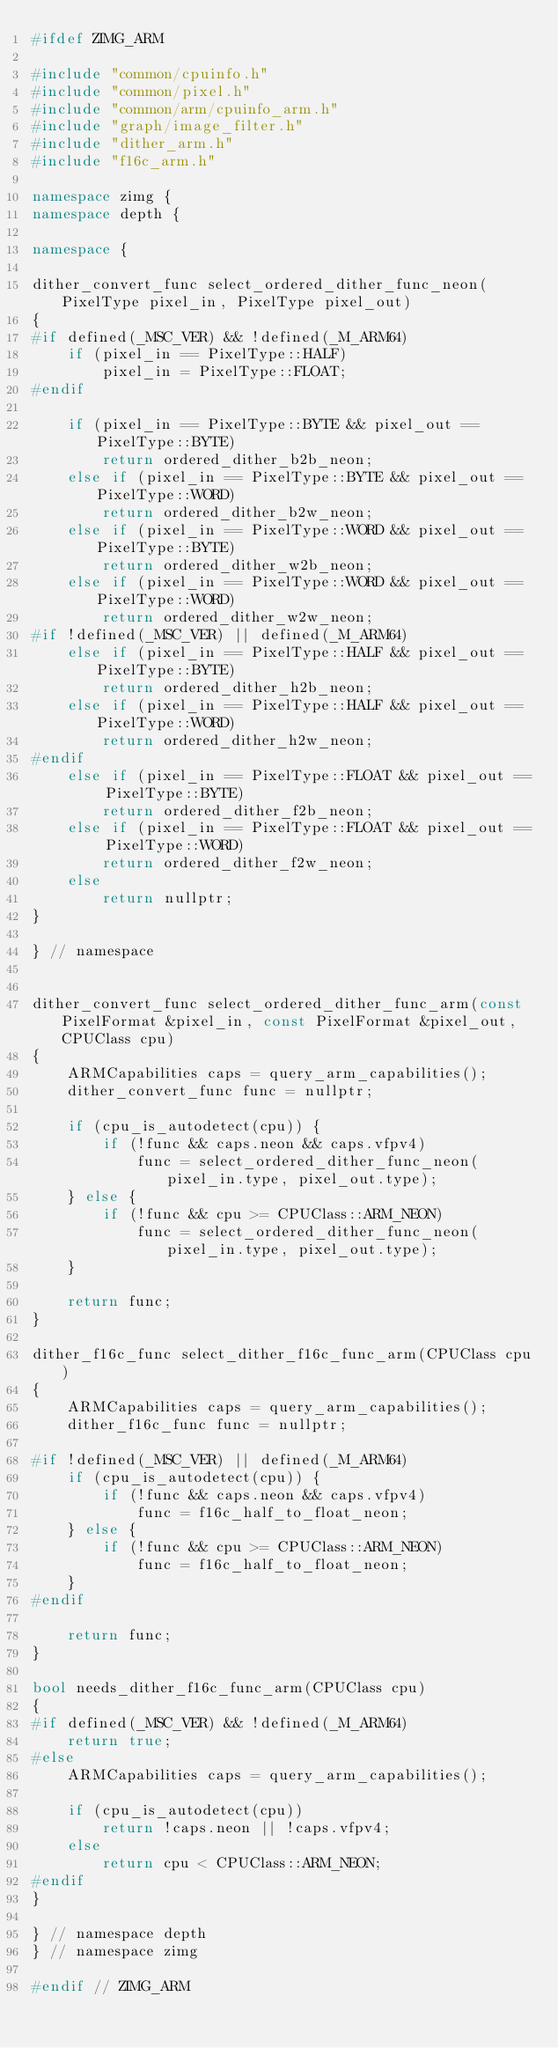Convert code to text. <code><loc_0><loc_0><loc_500><loc_500><_C++_>#ifdef ZIMG_ARM

#include "common/cpuinfo.h"
#include "common/pixel.h"
#include "common/arm/cpuinfo_arm.h"
#include "graph/image_filter.h"
#include "dither_arm.h"
#include "f16c_arm.h"

namespace zimg {
namespace depth {

namespace {

dither_convert_func select_ordered_dither_func_neon(PixelType pixel_in, PixelType pixel_out)
{
#if defined(_MSC_VER) && !defined(_M_ARM64)
	if (pixel_in == PixelType::HALF)
		pixel_in = PixelType::FLOAT;
#endif

	if (pixel_in == PixelType::BYTE && pixel_out == PixelType::BYTE)
		return ordered_dither_b2b_neon;
	else if (pixel_in == PixelType::BYTE && pixel_out == PixelType::WORD)
		return ordered_dither_b2w_neon;
	else if (pixel_in == PixelType::WORD && pixel_out == PixelType::BYTE)
		return ordered_dither_w2b_neon;
	else if (pixel_in == PixelType::WORD && pixel_out == PixelType::WORD)
		return ordered_dither_w2w_neon;
#if !defined(_MSC_VER) || defined(_M_ARM64)
	else if (pixel_in == PixelType::HALF && pixel_out == PixelType::BYTE)
		return ordered_dither_h2b_neon;
	else if (pixel_in == PixelType::HALF && pixel_out == PixelType::WORD)
		return ordered_dither_h2w_neon;
#endif
	else if (pixel_in == PixelType::FLOAT && pixel_out == PixelType::BYTE)
		return ordered_dither_f2b_neon;
	else if (pixel_in == PixelType::FLOAT && pixel_out == PixelType::WORD)
		return ordered_dither_f2w_neon;
	else
		return nullptr;
}

} // namespace


dither_convert_func select_ordered_dither_func_arm(const PixelFormat &pixel_in, const PixelFormat &pixel_out, CPUClass cpu)
{
	ARMCapabilities caps = query_arm_capabilities();
	dither_convert_func func = nullptr;

	if (cpu_is_autodetect(cpu)) {
		if (!func && caps.neon && caps.vfpv4)
			func = select_ordered_dither_func_neon(pixel_in.type, pixel_out.type);
	} else {
		if (!func && cpu >= CPUClass::ARM_NEON)
			func = select_ordered_dither_func_neon(pixel_in.type, pixel_out.type);
	}

	return func;
}

dither_f16c_func select_dither_f16c_func_arm(CPUClass cpu)
{
	ARMCapabilities caps = query_arm_capabilities();
	dither_f16c_func func = nullptr;

#if !defined(_MSC_VER) || defined(_M_ARM64)
	if (cpu_is_autodetect(cpu)) {
		if (!func && caps.neon && caps.vfpv4)
			func = f16c_half_to_float_neon;
	} else {
		if (!func && cpu >= CPUClass::ARM_NEON)
			func = f16c_half_to_float_neon;
	}
#endif

	return func;
}

bool needs_dither_f16c_func_arm(CPUClass cpu)
{
#if defined(_MSC_VER) && !defined(_M_ARM64)
	return true;
#else
	ARMCapabilities caps = query_arm_capabilities();

	if (cpu_is_autodetect(cpu))
		return !caps.neon || !caps.vfpv4;
	else
		return cpu < CPUClass::ARM_NEON;
#endif
}

} // namespace depth
} // namespace zimg

#endif // ZIMG_ARM
</code> 